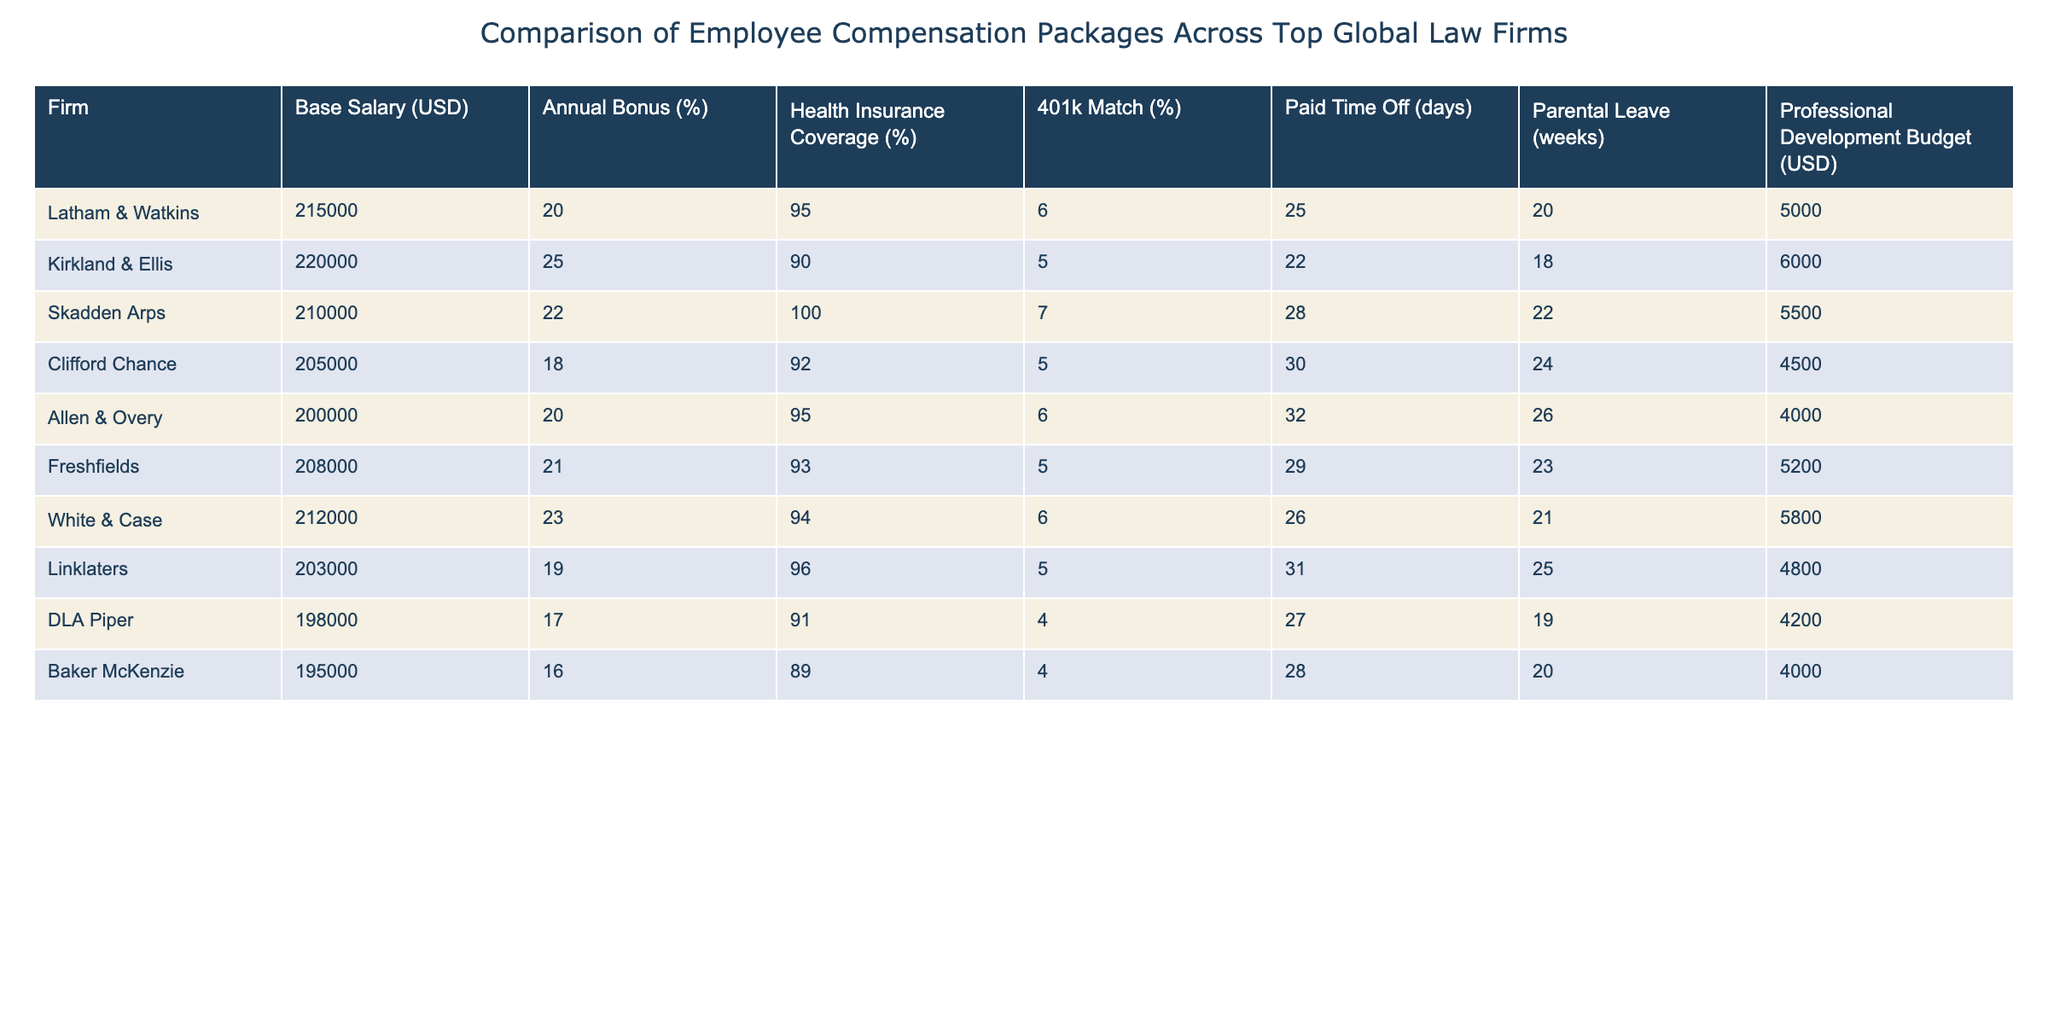What is the highest base salary among the firms? The table shows the base salaries for each firm. The highest listed salary is 220,000 from Kirkland & Ellis.
Answer: 220,000 Which firm offers the most generous annual bonus percentage? The table lists the annual bonus percentages for each firm. Kirkland & Ellis offers a bonus percentage of 25%, which is the highest.
Answer: 25% How many firms provide health insurance coverage above 90%? By looking at the health insurance coverage column, the firms with coverage above 90% are Skadden Arps, Allen & Overy, Freshfields, White & Case, and Linklaters. There are 5 such firms.
Answer: 5 What is the average paid time off (PTO) across all firms? The PTO days are 25, 22, 28, 30, 32, 29, 26, 31, 27, and 28 days. Summing these gives a total of  25 + 22 + 28 + 30 + 32 + 29 + 26 + 31 + 27 + 28 =  258. Dividing by the number of firms (10) gives an average of 25.8 days.
Answer: 25.8 Does any firm offer a 401k match of 6%? By checking the 401k match column, only Latham & Watkins and Allen & Overy offer a match of 6%. Therefore, the answer is yes.
Answer: Yes Which firm has the lowest parental leave weeks, and what is that value? The parental leave weeks for each firm are 20, 18, 22, 24, 26, 23, 21, 25, 19, and 20 weeks. The lowest value here is 18 weeks from Kirkland & Ellis.
Answer: 18 weeks What is the total professional development budget across all firms? The budget amounts are 5,000, 6,000, 5,500, 4,500, 4,000, 5,200, 5,800, 4,800, 4,200, and 4,000. Adding these gives a total of 55,500 USD across all firms.
Answer: 55,500 Which firm has the highest total compensation package when considering base salary and bonuses? To find the total compensation, we take the base salary and add the percentage of the annual bonus (e.g., for Kirkland & Ellis, it's 220,000 + (220,000 * 0.25) = 275,000). After performing this for each firm, Kirkland & Ellis has the highest total compensation of 275,000 USD.
Answer: 275,000 Is there a firm that provides paid time off less than 25 days? Looking at the PTO days column, DLA Piper and Baker McKenzie both provide 27 and 28 days respectively, which is more than 25 days. Therefore, no firm provides less than 25 days of PTO.
Answer: No What is the difference in health insurance coverage between the highest and lowest rated firms? The highest health insurance coverage is 100% by Skadden Arps, and the lowest is 89% by Baker McKenzie. The difference is therefore 100 - 89 = 11%.
Answer: 11% 